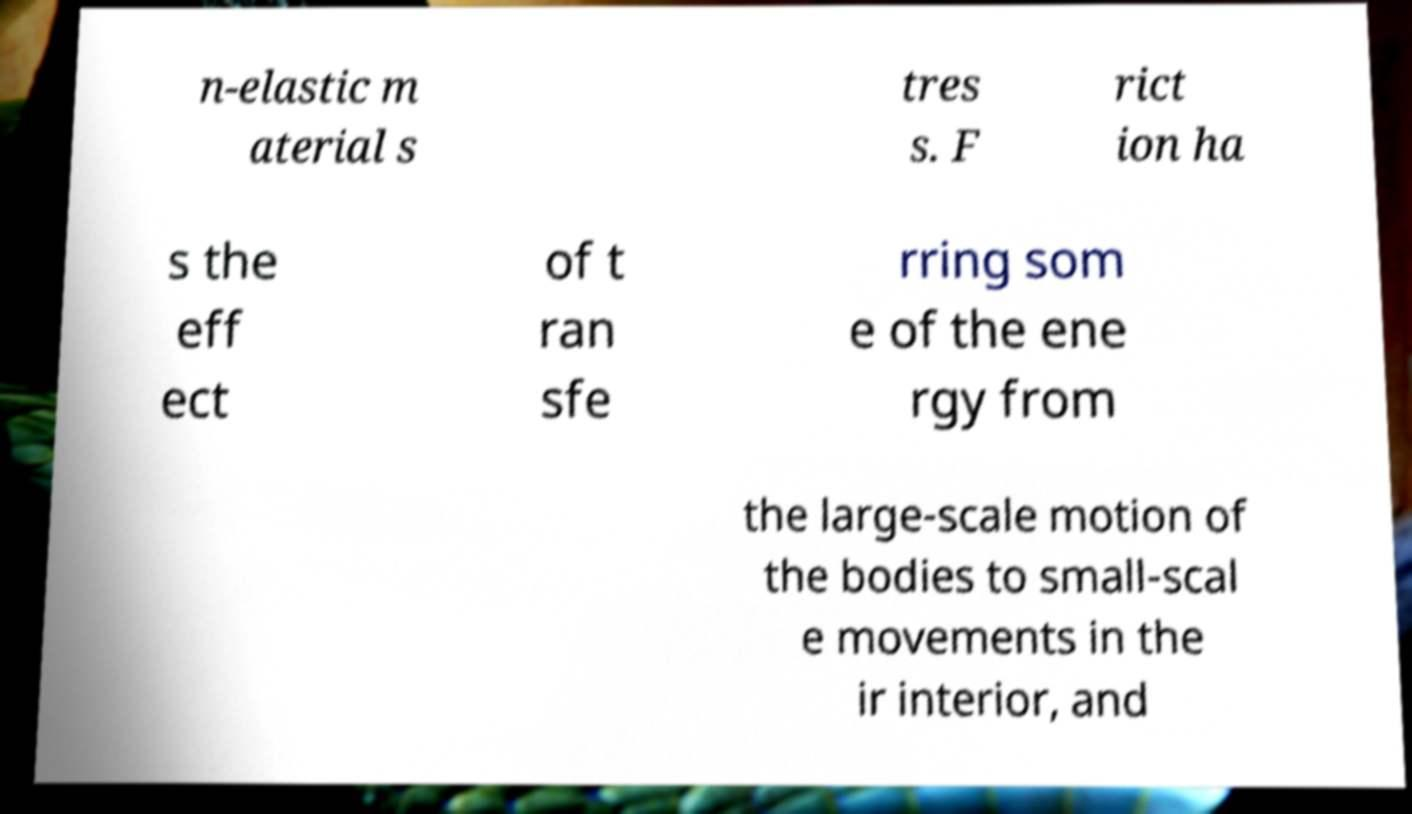Can you accurately transcribe the text from the provided image for me? n-elastic m aterial s tres s. F rict ion ha s the eff ect of t ran sfe rring som e of the ene rgy from the large-scale motion of the bodies to small-scal e movements in the ir interior, and 